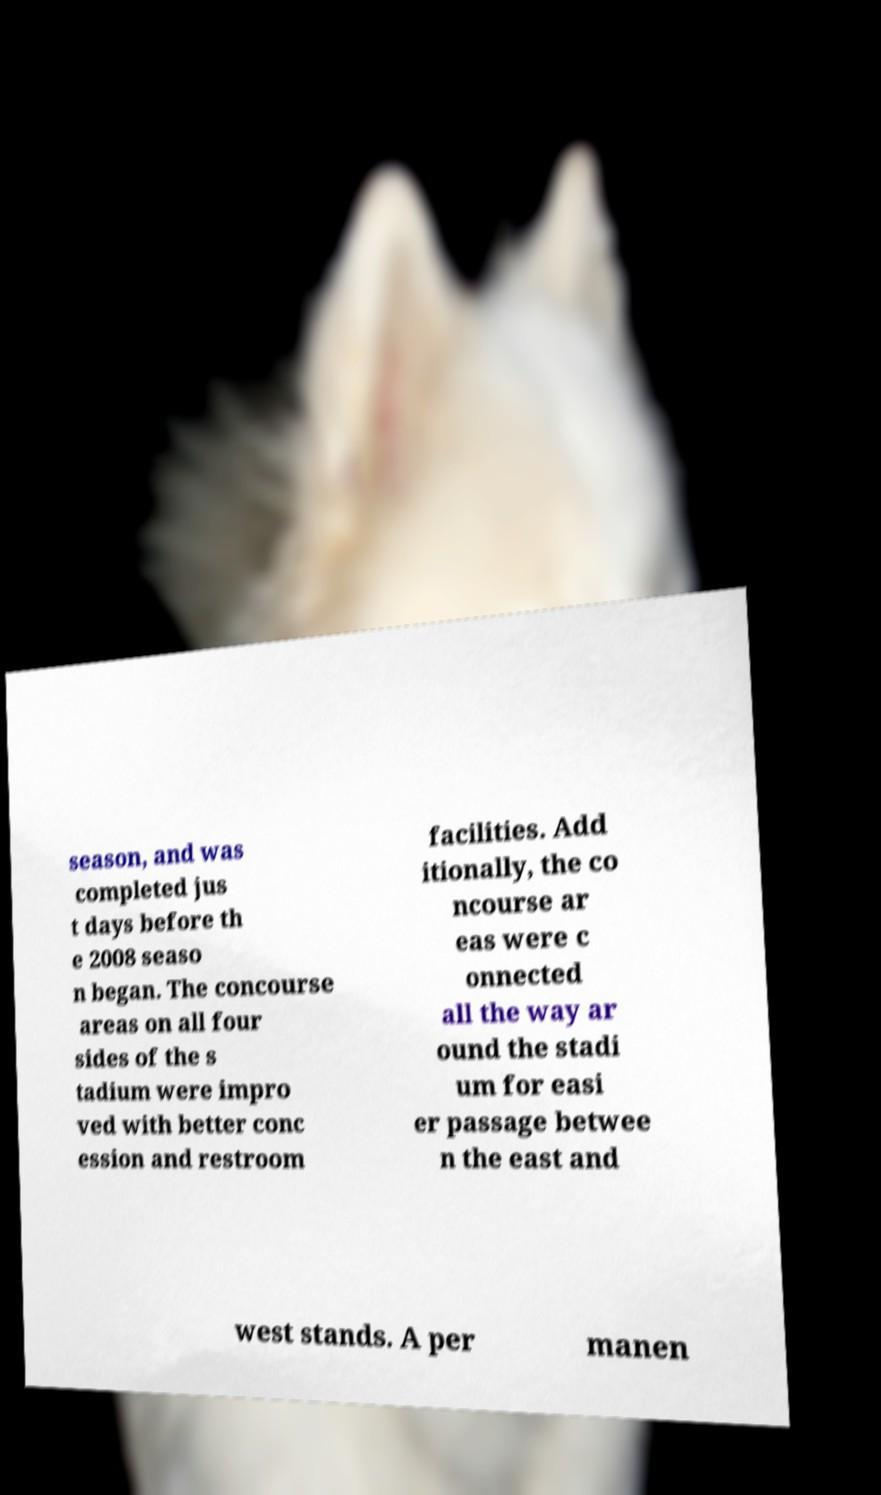Could you extract and type out the text from this image? season, and was completed jus t days before th e 2008 seaso n began. The concourse areas on all four sides of the s tadium were impro ved with better conc ession and restroom facilities. Add itionally, the co ncourse ar eas were c onnected all the way ar ound the stadi um for easi er passage betwee n the east and west stands. A per manen 